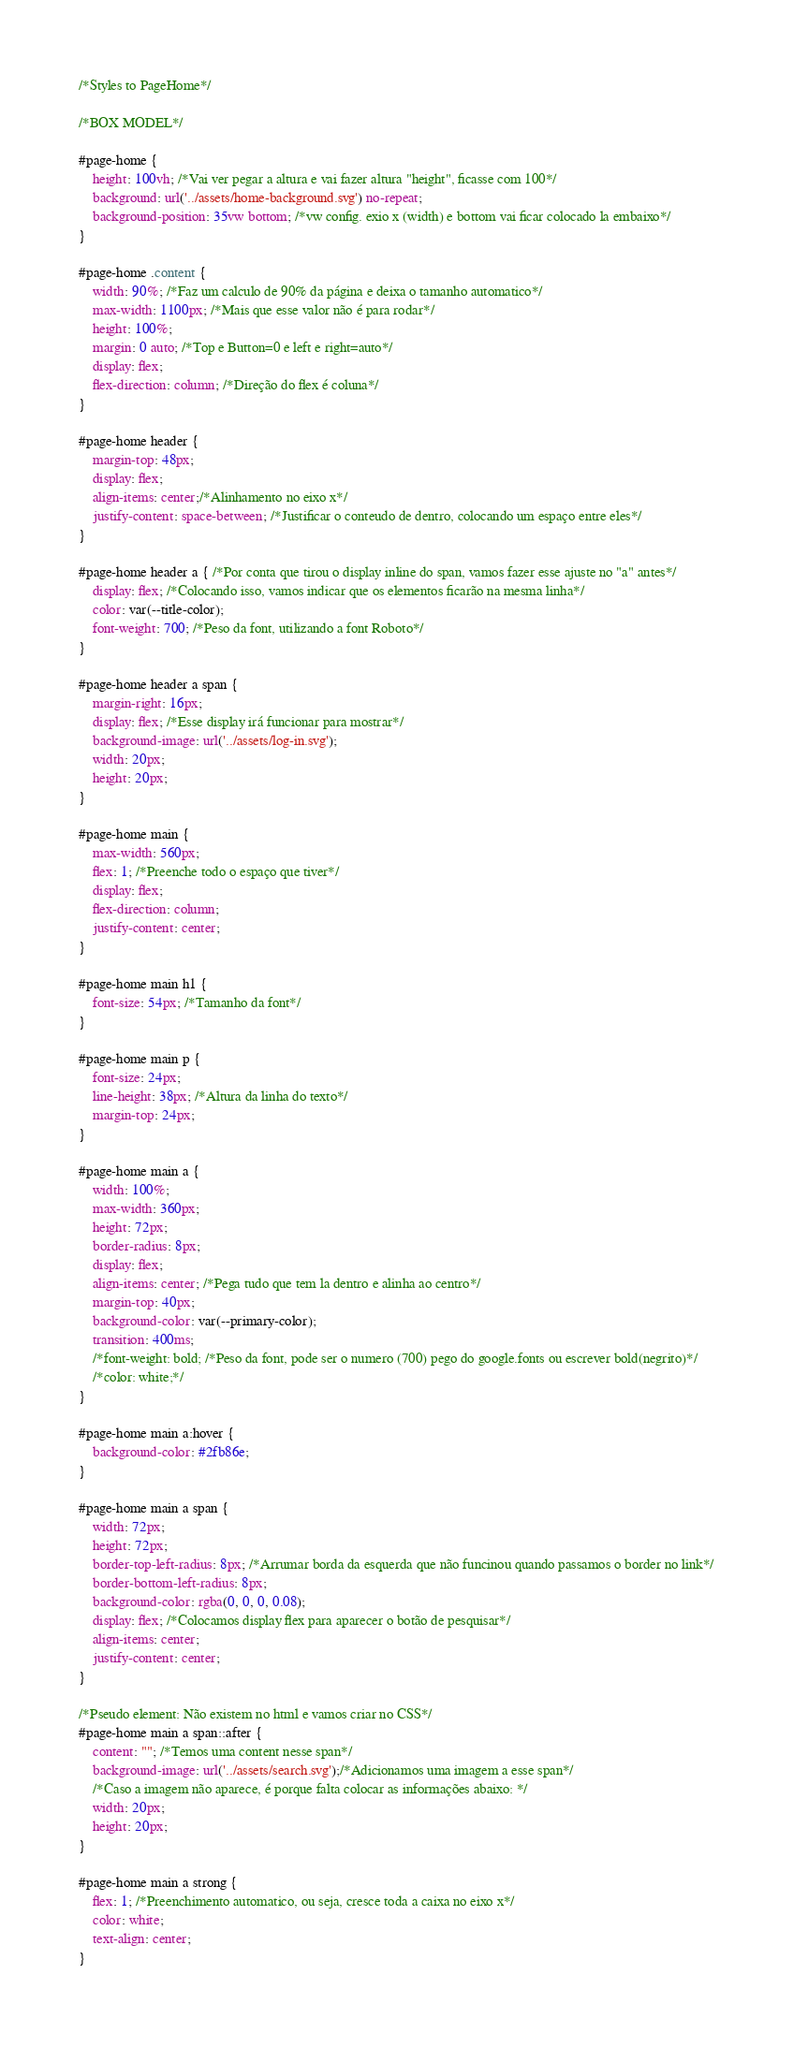<code> <loc_0><loc_0><loc_500><loc_500><_CSS_>/*Styles to PageHome*/

/*BOX MODEL*/

#page-home {
    height: 100vh; /*Vai ver pegar a altura e vai fazer altura "height", ficasse com 100*/
    background: url('../assets/home-background.svg') no-repeat;
    background-position: 35vw bottom; /*vw config. exio x (width) e bottom vai ficar colocado la embaixo*/
}

#page-home .content {
    width: 90%; /*Faz um calculo de 90% da página e deixa o tamanho automatico*/
    max-width: 1100px; /*Mais que esse valor não é para rodar*/
    height: 100%;
    margin: 0 auto; /*Top e Button=0 e left e right=auto*/
    display: flex;
    flex-direction: column; /*Direção do flex é coluna*/
}

#page-home header {
    margin-top: 48px;
    display: flex;
    align-items: center;/*Alinhamento no eixo x*/
    justify-content: space-between; /*Justificar o conteudo de dentro, colocando um espaço entre eles*/     
}

#page-home header a { /*Por conta que tirou o display inline do span, vamos fazer esse ajuste no "a" antes*/
    display: flex; /*Colocando isso, vamos indicar que os elementos ficarão na mesma linha*/
    color: var(--title-color);
    font-weight: 700; /*Peso da font, utilizando a font Roboto*/    
}

#page-home header a span {
    margin-right: 16px;
    display: flex; /*Esse display irá funcionar para mostrar*/
    background-image: url('../assets/log-in.svg');
    width: 20px;
    height: 20px;
}

#page-home main {
    max-width: 560px;
    flex: 1; /*Preenche todo o espaço que tiver*/
    display: flex;
    flex-direction: column;
    justify-content: center;
}

#page-home main h1 {
    font-size: 54px; /*Tamanho da font*/
}

#page-home main p {
    font-size: 24px;
    line-height: 38px; /*Altura da linha do texto*/
    margin-top: 24px;
}

#page-home main a {
    width: 100%;
    max-width: 360px;
    height: 72px;
    border-radius: 8px;
    display: flex;
    align-items: center; /*Pega tudo que tem la dentro e alinha ao centro*/
    margin-top: 40px;
    background-color: var(--primary-color);
    transition: 400ms;
    /*font-weight: bold; /*Peso da font, pode ser o numero (700) pego do google.fonts ou escrever bold(negrito)*/
    /*color: white;*/
}

#page-home main a:hover {
    background-color: #2fb86e;
}

#page-home main a span {
    width: 72px;
    height: 72px;
    border-top-left-radius: 8px; /*Arrumar borda da esquerda que não funcinou quando passamos o border no link*/
    border-bottom-left-radius: 8px;
    background-color: rgba(0, 0, 0, 0.08);
    display: flex; /*Colocamos display flex para aparecer o botão de pesquisar*/
    align-items: center;
    justify-content: center;
}

/*Pseudo element: Não existem no html e vamos criar no CSS*/
#page-home main a span::after {
    content: ""; /*Temos uma content nesse span*/
    background-image: url('../assets/search.svg');/*Adicionamos uma imagem a esse span*/
    /*Caso a imagem não aparece, é porque falta colocar as informações abaixo: */
    width: 20px;
    height: 20px;
}

#page-home main a strong {
    flex: 1; /*Preenchimento automatico, ou seja, cresce toda a caixa no eixo x*/
    color: white;
    text-align: center;
}</code> 